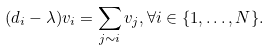<formula> <loc_0><loc_0><loc_500><loc_500>( d _ { i } - \lambda ) v _ { i } = \sum _ { j \sim i } v _ { j } , \forall i \in \{ 1 , \dots , N \} .</formula> 